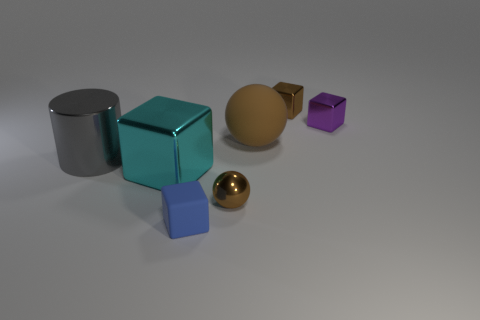What is the small brown object that is in front of the cyan shiny block made of?
Provide a short and direct response. Metal. Is the color of the matte object that is right of the blue rubber cube the same as the small metallic object in front of the cyan object?
Ensure brevity in your answer.  Yes. The rubber thing that is the same size as the gray shiny cylinder is what color?
Make the answer very short. Brown. What number of other objects are there of the same shape as the gray thing?
Offer a terse response. 0. There is a matte object that is in front of the cyan metal block; how big is it?
Make the answer very short. Small. There is a big sphere to the right of the blue matte thing; what number of metallic things are in front of it?
Make the answer very short. 3. What number of other things are there of the same size as the purple cube?
Your response must be concise. 3. Does the cylinder have the same color as the tiny sphere?
Offer a terse response. No. There is a tiny object behind the small purple shiny thing; does it have the same shape as the blue object?
Offer a terse response. Yes. What number of objects are to the right of the large shiny cylinder and left of the blue rubber block?
Ensure brevity in your answer.  1. 